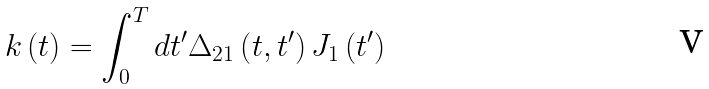Convert formula to latex. <formula><loc_0><loc_0><loc_500><loc_500>k \left ( t \right ) = \int _ { 0 } ^ { T } d t ^ { \prime } \Delta _ { 2 1 } \left ( t , t ^ { \prime } \right ) J _ { 1 } \left ( t ^ { \prime } \right )</formula> 